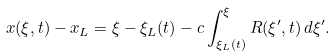<formula> <loc_0><loc_0><loc_500><loc_500>x ( \xi , t ) - x _ { L } = \xi - \xi _ { L } ( t ) - c \int _ { \xi _ { L } ( t ) } ^ { \xi } R ( \xi ^ { \prime } , t ) \, d \xi ^ { \prime } .</formula> 